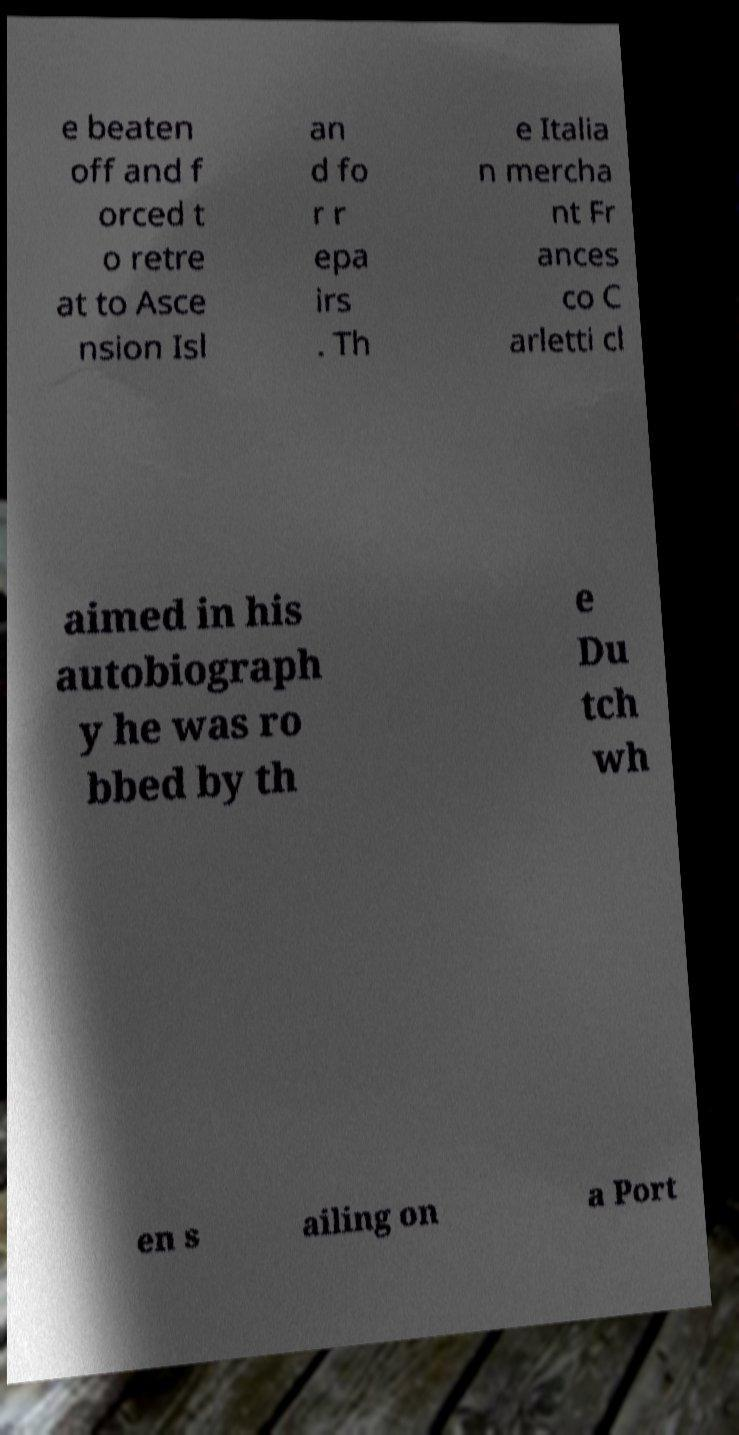What messages or text are displayed in this image? I need them in a readable, typed format. e beaten off and f orced t o retre at to Asce nsion Isl an d fo r r epa irs . Th e Italia n mercha nt Fr ances co C arletti cl aimed in his autobiograph y he was ro bbed by th e Du tch wh en s ailing on a Port 